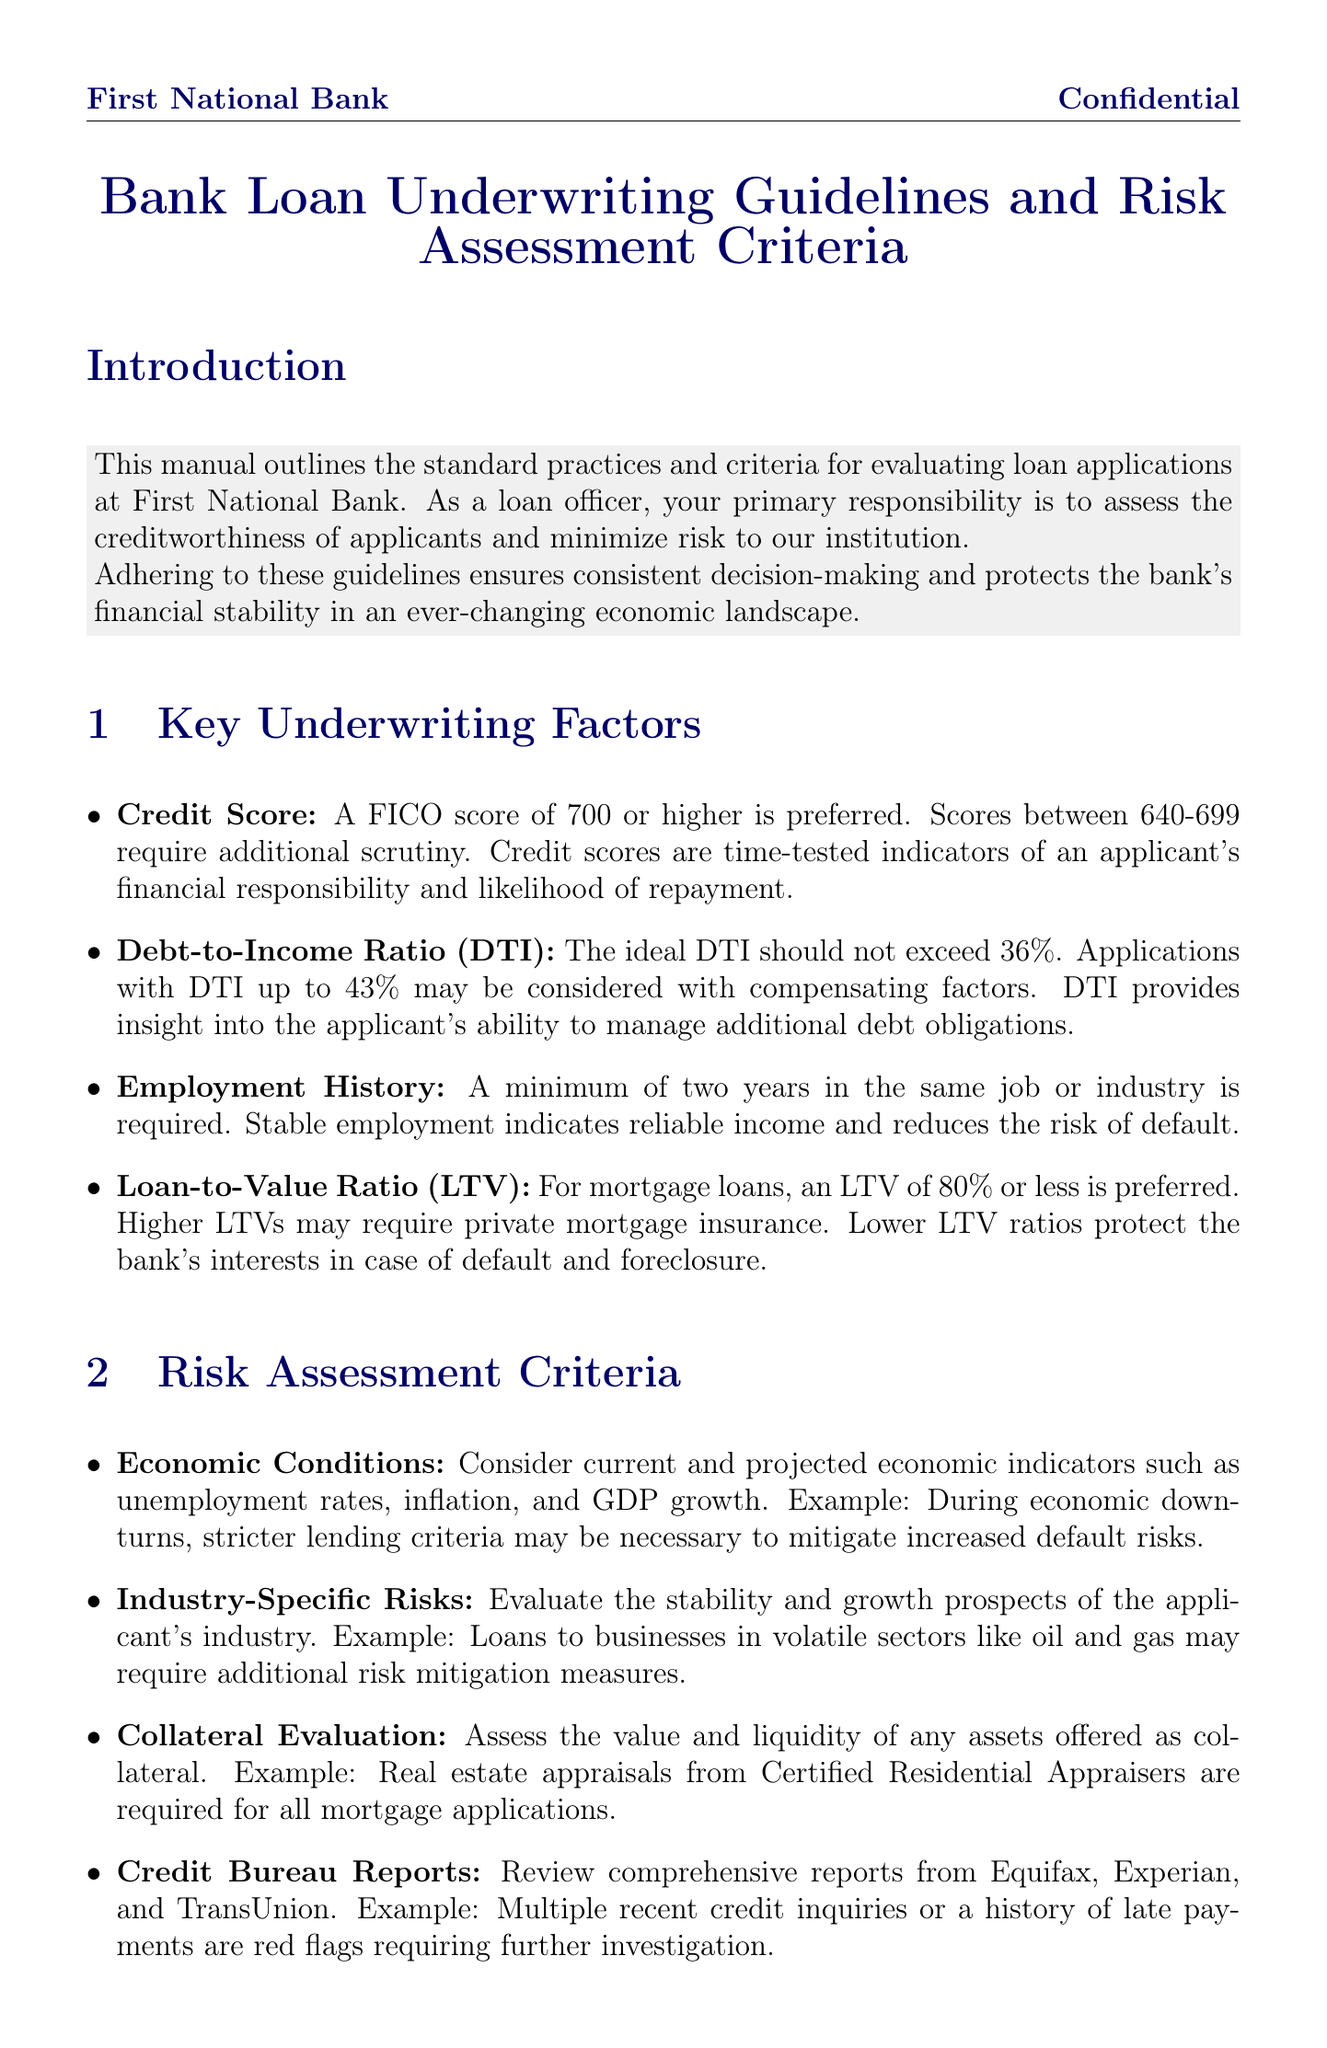What is the preferred credit score? The document states that a FICO score of 700 or higher is preferred.
Answer: 700 What is the maximum acceptable Debt-to-Income Ratio? According to the guidelines, the ideal DTI should not exceed 36%.
Answer: 36% How many years of employment history is required? The manual specifies that a minimum of two years in the same job or industry is required.
Answer: Two years What is the acceptable Loan-to-Value Ratio for mortgage loans? The document indicates that an LTV of 80% or less is preferred for mortgage loans.
Answer: 80% What examples of economic indicators should be considered? The manual mentions unemployment rates, inflation, and GDP growth as indicators.
Answer: Unemployment rates, inflation, and GDP growth What are the documentation requirements for proof of income? The guidelines require W-2 forms and tax returns for the past two years as proof of income.
Answer: W-2 forms, tax returns for the past two years Which act ensures equal credit opportunities? The document lists the Equal Credit Opportunity Act as one of the regulations to comply with.
Answer: Equal Credit Opportunity Act What is the warning regarding alternative financing methods? The document warns to be cautious of non-traditional financing methods like peer-to-peer lending.
Answer: Cautious of non-traditional financing methods Are exceptions to the guidelines allowed? The conclusion states that exceptions may be considered with appropriate justification and senior approval.
Answer: Yes, with justification and senior approval 